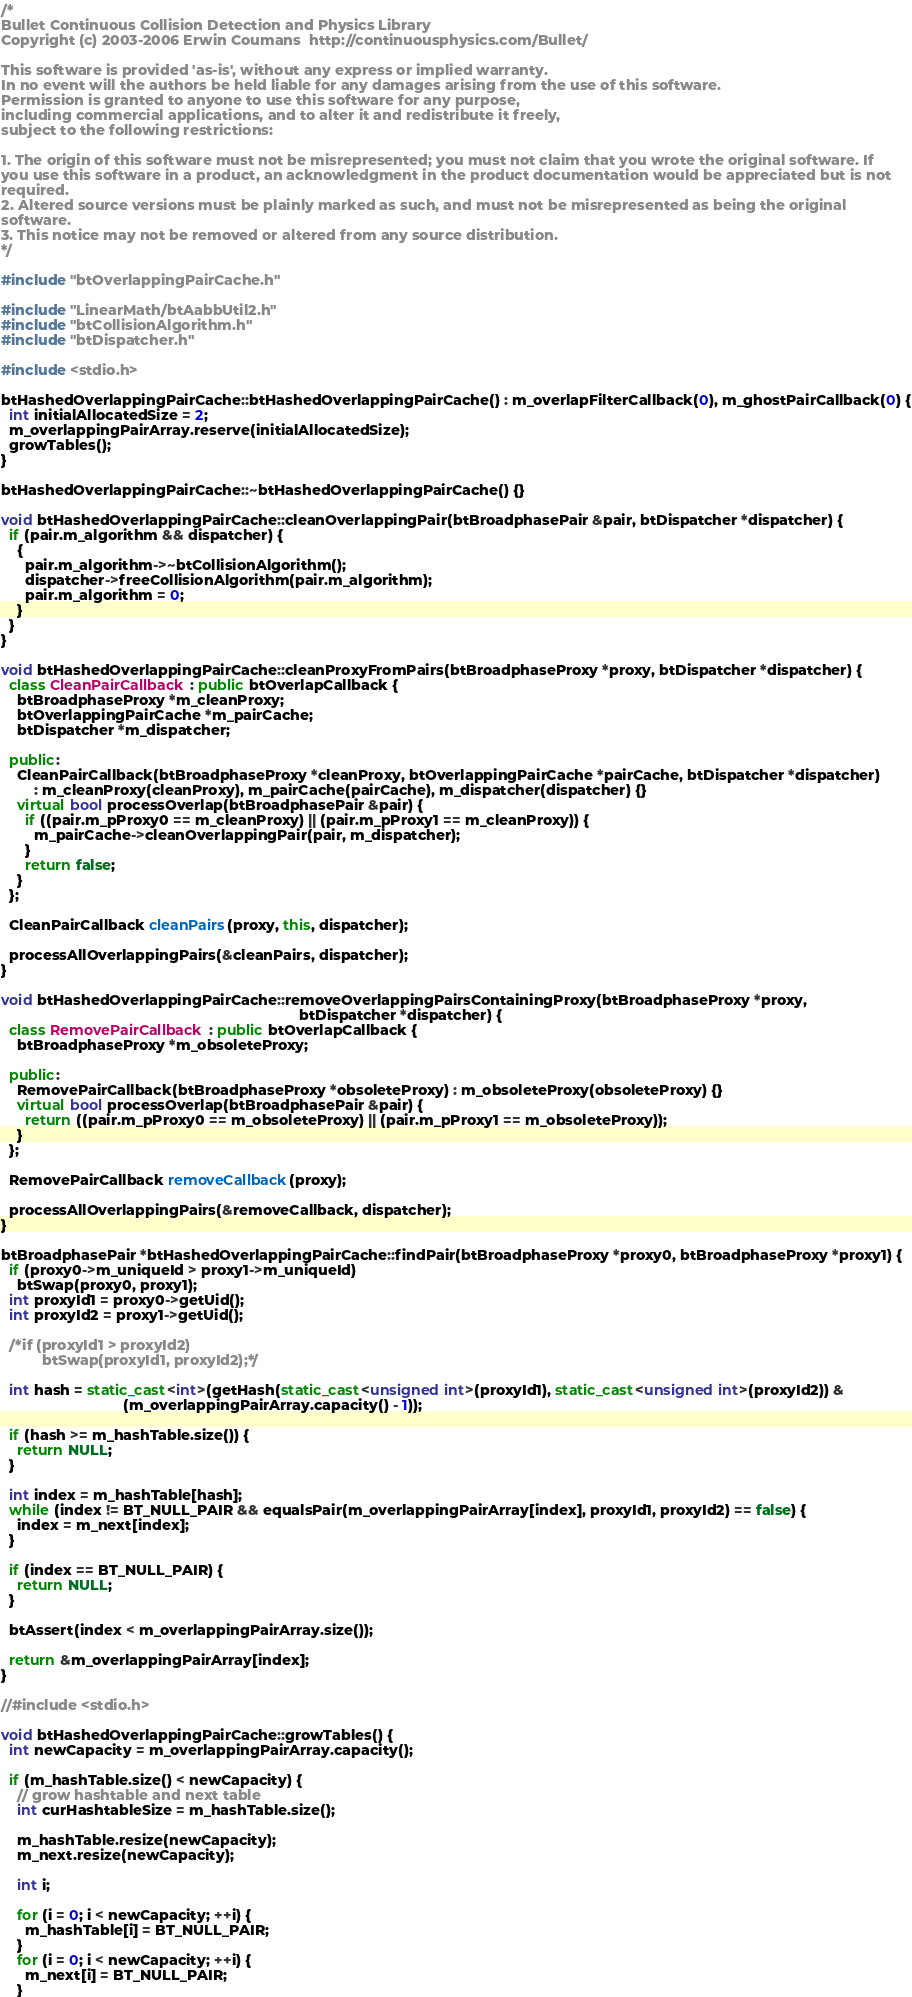Convert code to text. <code><loc_0><loc_0><loc_500><loc_500><_C++_>/*
Bullet Continuous Collision Detection and Physics Library
Copyright (c) 2003-2006 Erwin Coumans  http://continuousphysics.com/Bullet/

This software is provided 'as-is', without any express or implied warranty.
In no event will the authors be held liable for any damages arising from the use of this software.
Permission is granted to anyone to use this software for any purpose,
including commercial applications, and to alter it and redistribute it freely,
subject to the following restrictions:

1. The origin of this software must not be misrepresented; you must not claim that you wrote the original software. If
you use this software in a product, an acknowledgment in the product documentation would be appreciated but is not
required.
2. Altered source versions must be plainly marked as such, and must not be misrepresented as being the original
software.
3. This notice may not be removed or altered from any source distribution.
*/

#include "btOverlappingPairCache.h"

#include "LinearMath/btAabbUtil2.h"
#include "btCollisionAlgorithm.h"
#include "btDispatcher.h"

#include <stdio.h>

btHashedOverlappingPairCache::btHashedOverlappingPairCache() : m_overlapFilterCallback(0), m_ghostPairCallback(0) {
  int initialAllocatedSize = 2;
  m_overlappingPairArray.reserve(initialAllocatedSize);
  growTables();
}

btHashedOverlappingPairCache::~btHashedOverlappingPairCache() {}

void btHashedOverlappingPairCache::cleanOverlappingPair(btBroadphasePair &pair, btDispatcher *dispatcher) {
  if (pair.m_algorithm && dispatcher) {
    {
      pair.m_algorithm->~btCollisionAlgorithm();
      dispatcher->freeCollisionAlgorithm(pair.m_algorithm);
      pair.m_algorithm = 0;
    }
  }
}

void btHashedOverlappingPairCache::cleanProxyFromPairs(btBroadphaseProxy *proxy, btDispatcher *dispatcher) {
  class CleanPairCallback : public btOverlapCallback {
    btBroadphaseProxy *m_cleanProxy;
    btOverlappingPairCache *m_pairCache;
    btDispatcher *m_dispatcher;

  public:
    CleanPairCallback(btBroadphaseProxy *cleanProxy, btOverlappingPairCache *pairCache, btDispatcher *dispatcher)
        : m_cleanProxy(cleanProxy), m_pairCache(pairCache), m_dispatcher(dispatcher) {}
    virtual bool processOverlap(btBroadphasePair &pair) {
      if ((pair.m_pProxy0 == m_cleanProxy) || (pair.m_pProxy1 == m_cleanProxy)) {
        m_pairCache->cleanOverlappingPair(pair, m_dispatcher);
      }
      return false;
    }
  };

  CleanPairCallback cleanPairs(proxy, this, dispatcher);

  processAllOverlappingPairs(&cleanPairs, dispatcher);
}

void btHashedOverlappingPairCache::removeOverlappingPairsContainingProxy(btBroadphaseProxy *proxy,
                                                                         btDispatcher *dispatcher) {
  class RemovePairCallback : public btOverlapCallback {
    btBroadphaseProxy *m_obsoleteProxy;

  public:
    RemovePairCallback(btBroadphaseProxy *obsoleteProxy) : m_obsoleteProxy(obsoleteProxy) {}
    virtual bool processOverlap(btBroadphasePair &pair) {
      return ((pair.m_pProxy0 == m_obsoleteProxy) || (pair.m_pProxy1 == m_obsoleteProxy));
    }
  };

  RemovePairCallback removeCallback(proxy);

  processAllOverlappingPairs(&removeCallback, dispatcher);
}

btBroadphasePair *btHashedOverlappingPairCache::findPair(btBroadphaseProxy *proxy0, btBroadphaseProxy *proxy1) {
  if (proxy0->m_uniqueId > proxy1->m_uniqueId)
    btSwap(proxy0, proxy1);
  int proxyId1 = proxy0->getUid();
  int proxyId2 = proxy1->getUid();

  /*if (proxyId1 > proxyId2)
          btSwap(proxyId1, proxyId2);*/

  int hash = static_cast<int>(getHash(static_cast<unsigned int>(proxyId1), static_cast<unsigned int>(proxyId2)) &
                              (m_overlappingPairArray.capacity() - 1));

  if (hash >= m_hashTable.size()) {
    return NULL;
  }

  int index = m_hashTable[hash];
  while (index != BT_NULL_PAIR && equalsPair(m_overlappingPairArray[index], proxyId1, proxyId2) == false) {
    index = m_next[index];
  }

  if (index == BT_NULL_PAIR) {
    return NULL;
  }

  btAssert(index < m_overlappingPairArray.size());

  return &m_overlappingPairArray[index];
}

//#include <stdio.h>

void btHashedOverlappingPairCache::growTables() {
  int newCapacity = m_overlappingPairArray.capacity();

  if (m_hashTable.size() < newCapacity) {
    // grow hashtable and next table
    int curHashtableSize = m_hashTable.size();

    m_hashTable.resize(newCapacity);
    m_next.resize(newCapacity);

    int i;

    for (i = 0; i < newCapacity; ++i) {
      m_hashTable[i] = BT_NULL_PAIR;
    }
    for (i = 0; i < newCapacity; ++i) {
      m_next[i] = BT_NULL_PAIR;
    }
</code> 